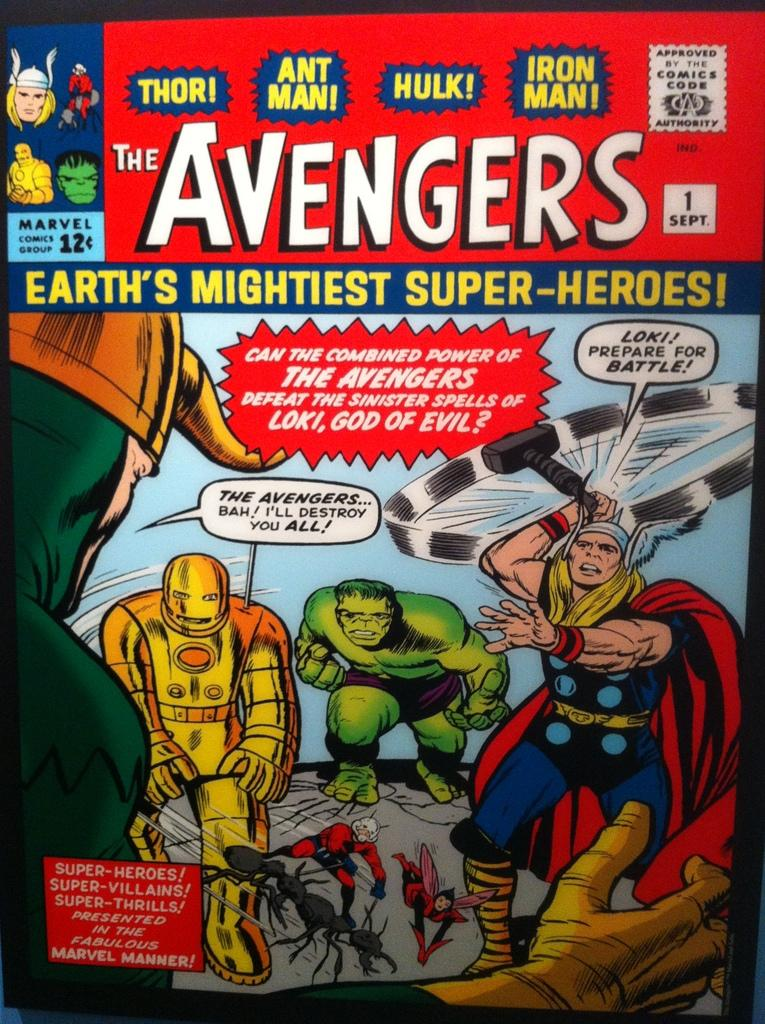Provide a one-sentence caption for the provided image. A copy of the Avengers comic book that sold for 12 cents. 